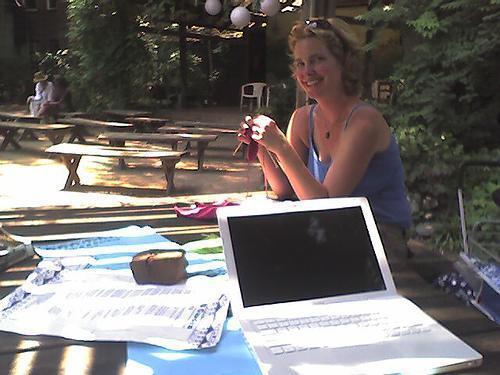How many people are in the picture?
Give a very brief answer. 2. 